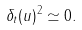Convert formula to latex. <formula><loc_0><loc_0><loc_500><loc_500>\delta _ { t } ( u ) ^ { 2 } \simeq 0 .</formula> 